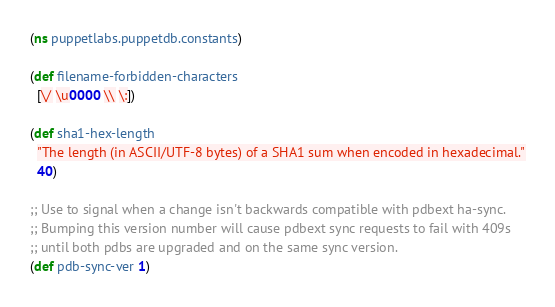<code> <loc_0><loc_0><loc_500><loc_500><_Clojure_>(ns puppetlabs.puppetdb.constants)

(def filename-forbidden-characters
  [\/ \u0000 \\ \:])

(def sha1-hex-length
  "The length (in ASCII/UTF-8 bytes) of a SHA1 sum when encoded in hexadecimal."
  40)

;; Use to signal when a change isn't backwards compatible with pdbext ha-sync.
;; Bumping this version number will cause pdbext sync requests to fail with 409s
;; until both pdbs are upgraded and on the same sync version.
(def pdb-sync-ver 1)
</code> 